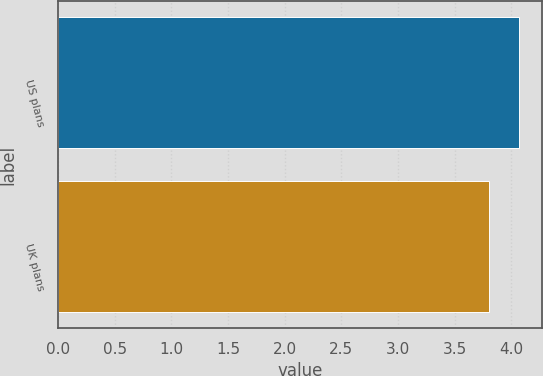Convert chart. <chart><loc_0><loc_0><loc_500><loc_500><bar_chart><fcel>US plans<fcel>UK plans<nl><fcel>4.07<fcel>3.8<nl></chart> 